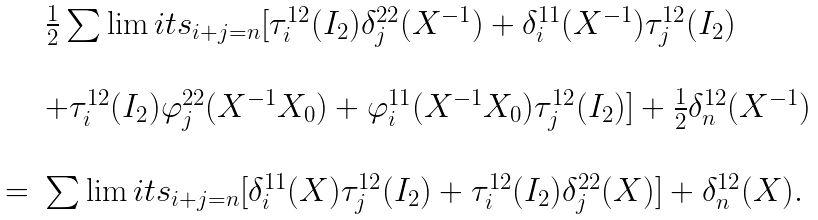<formula> <loc_0><loc_0><loc_500><loc_500>\begin{array} { r c l } & & \frac { 1 } { 2 } \sum \lim i t s _ { i + j = n } [ \tau _ { i } ^ { 1 2 } ( I _ { 2 } ) \delta _ { j } ^ { 2 2 } ( X ^ { - 1 } ) + \delta _ { i } ^ { 1 1 } ( X ^ { - 1 } ) \tau _ { j } ^ { 1 2 } ( I _ { 2 } ) \\ \\ & & + \tau _ { i } ^ { 1 2 } ( I _ { 2 } ) \varphi _ { j } ^ { 2 2 } ( X ^ { - 1 } X _ { 0 } ) + \varphi _ { i } ^ { 1 1 } ( X ^ { - 1 } X _ { 0 } ) \tau _ { j } ^ { 1 2 } ( I _ { 2 } ) ] + \frac { 1 } { 2 } \delta _ { n } ^ { 1 2 } ( X ^ { - 1 } ) \\ \\ & = & \sum \lim i t s _ { i + j = n } [ \delta _ { i } ^ { 1 1 } ( X ) \tau _ { j } ^ { 1 2 } ( I _ { 2 } ) + \tau _ { i } ^ { 1 2 } ( I _ { 2 } ) \delta _ { j } ^ { 2 2 } ( X ) ] + \delta _ { n } ^ { 1 2 } ( X ) . \end{array}</formula> 